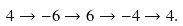Convert formula to latex. <formula><loc_0><loc_0><loc_500><loc_500>4 \rightarrow - 6 \rightarrow 6 \rightarrow - 4 \rightarrow 4 .</formula> 